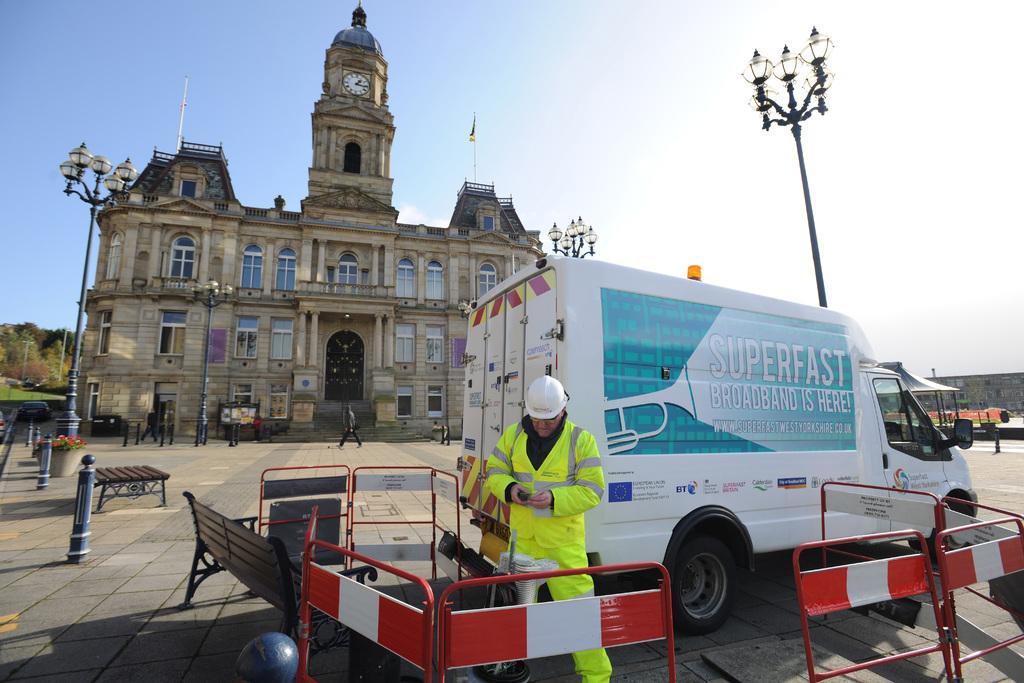Describe this image in one or two sentences. In this picture we can see a vehicle and a person standing on the road, benches, poles, fence, trees, building with windows, some persons walking and in the background we can see the sky. 